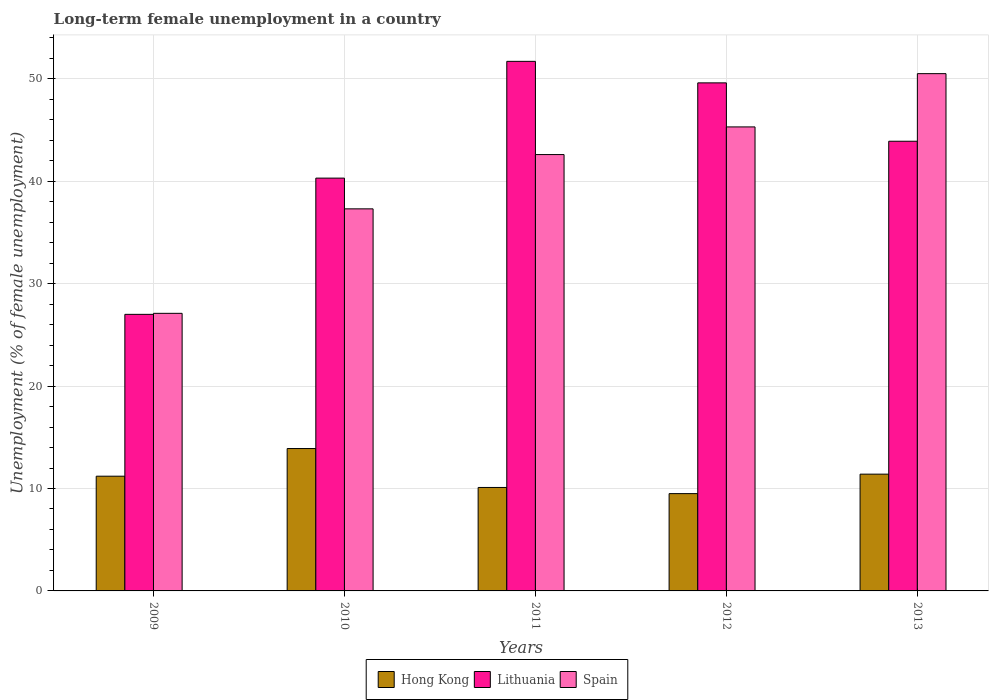How many different coloured bars are there?
Provide a succinct answer. 3. Are the number of bars on each tick of the X-axis equal?
Keep it short and to the point. Yes. How many bars are there on the 2nd tick from the left?
Provide a short and direct response. 3. How many bars are there on the 2nd tick from the right?
Offer a terse response. 3. In how many cases, is the number of bars for a given year not equal to the number of legend labels?
Your answer should be very brief. 0. What is the percentage of long-term unemployed female population in Hong Kong in 2013?
Offer a terse response. 11.4. Across all years, what is the maximum percentage of long-term unemployed female population in Lithuania?
Keep it short and to the point. 51.7. In which year was the percentage of long-term unemployed female population in Lithuania minimum?
Your response must be concise. 2009. What is the total percentage of long-term unemployed female population in Hong Kong in the graph?
Make the answer very short. 56.1. What is the difference between the percentage of long-term unemployed female population in Spain in 2009 and that in 2013?
Your response must be concise. -23.4. What is the difference between the percentage of long-term unemployed female population in Lithuania in 2010 and the percentage of long-term unemployed female population in Hong Kong in 2012?
Keep it short and to the point. 30.8. What is the average percentage of long-term unemployed female population in Hong Kong per year?
Your answer should be very brief. 11.22. In the year 2012, what is the difference between the percentage of long-term unemployed female population in Spain and percentage of long-term unemployed female population in Hong Kong?
Provide a short and direct response. 35.8. What is the ratio of the percentage of long-term unemployed female population in Lithuania in 2009 to that in 2010?
Keep it short and to the point. 0.67. What is the difference between the highest and the second highest percentage of long-term unemployed female population in Lithuania?
Your answer should be compact. 2.1. What is the difference between the highest and the lowest percentage of long-term unemployed female population in Spain?
Ensure brevity in your answer.  23.4. In how many years, is the percentage of long-term unemployed female population in Hong Kong greater than the average percentage of long-term unemployed female population in Hong Kong taken over all years?
Keep it short and to the point. 2. What does the 1st bar from the left in 2009 represents?
Offer a terse response. Hong Kong. What does the 3rd bar from the right in 2011 represents?
Your answer should be compact. Hong Kong. Is it the case that in every year, the sum of the percentage of long-term unemployed female population in Spain and percentage of long-term unemployed female population in Hong Kong is greater than the percentage of long-term unemployed female population in Lithuania?
Your answer should be compact. Yes. What is the difference between two consecutive major ticks on the Y-axis?
Provide a short and direct response. 10. Where does the legend appear in the graph?
Offer a very short reply. Bottom center. How are the legend labels stacked?
Your response must be concise. Horizontal. What is the title of the graph?
Provide a succinct answer. Long-term female unemployment in a country. Does "West Bank and Gaza" appear as one of the legend labels in the graph?
Offer a very short reply. No. What is the label or title of the Y-axis?
Give a very brief answer. Unemployment (% of female unemployment). What is the Unemployment (% of female unemployment) in Hong Kong in 2009?
Ensure brevity in your answer.  11.2. What is the Unemployment (% of female unemployment) of Spain in 2009?
Offer a very short reply. 27.1. What is the Unemployment (% of female unemployment) of Hong Kong in 2010?
Your response must be concise. 13.9. What is the Unemployment (% of female unemployment) of Lithuania in 2010?
Your response must be concise. 40.3. What is the Unemployment (% of female unemployment) of Spain in 2010?
Give a very brief answer. 37.3. What is the Unemployment (% of female unemployment) in Hong Kong in 2011?
Your answer should be compact. 10.1. What is the Unemployment (% of female unemployment) in Lithuania in 2011?
Give a very brief answer. 51.7. What is the Unemployment (% of female unemployment) in Spain in 2011?
Keep it short and to the point. 42.6. What is the Unemployment (% of female unemployment) in Lithuania in 2012?
Make the answer very short. 49.6. What is the Unemployment (% of female unemployment) of Spain in 2012?
Your answer should be very brief. 45.3. What is the Unemployment (% of female unemployment) of Hong Kong in 2013?
Your answer should be compact. 11.4. What is the Unemployment (% of female unemployment) in Lithuania in 2013?
Give a very brief answer. 43.9. What is the Unemployment (% of female unemployment) of Spain in 2013?
Your answer should be very brief. 50.5. Across all years, what is the maximum Unemployment (% of female unemployment) in Hong Kong?
Give a very brief answer. 13.9. Across all years, what is the maximum Unemployment (% of female unemployment) of Lithuania?
Offer a terse response. 51.7. Across all years, what is the maximum Unemployment (% of female unemployment) of Spain?
Make the answer very short. 50.5. Across all years, what is the minimum Unemployment (% of female unemployment) in Spain?
Provide a succinct answer. 27.1. What is the total Unemployment (% of female unemployment) in Hong Kong in the graph?
Give a very brief answer. 56.1. What is the total Unemployment (% of female unemployment) in Lithuania in the graph?
Make the answer very short. 212.5. What is the total Unemployment (% of female unemployment) in Spain in the graph?
Your response must be concise. 202.8. What is the difference between the Unemployment (% of female unemployment) in Spain in 2009 and that in 2010?
Provide a short and direct response. -10.2. What is the difference between the Unemployment (% of female unemployment) in Lithuania in 2009 and that in 2011?
Provide a succinct answer. -24.7. What is the difference between the Unemployment (% of female unemployment) in Spain in 2009 and that in 2011?
Your response must be concise. -15.5. What is the difference between the Unemployment (% of female unemployment) of Lithuania in 2009 and that in 2012?
Provide a short and direct response. -22.6. What is the difference between the Unemployment (% of female unemployment) of Spain in 2009 and that in 2012?
Your response must be concise. -18.2. What is the difference between the Unemployment (% of female unemployment) of Lithuania in 2009 and that in 2013?
Give a very brief answer. -16.9. What is the difference between the Unemployment (% of female unemployment) in Spain in 2009 and that in 2013?
Give a very brief answer. -23.4. What is the difference between the Unemployment (% of female unemployment) of Lithuania in 2010 and that in 2011?
Offer a very short reply. -11.4. What is the difference between the Unemployment (% of female unemployment) of Hong Kong in 2010 and that in 2012?
Offer a very short reply. 4.4. What is the difference between the Unemployment (% of female unemployment) of Lithuania in 2011 and that in 2012?
Your answer should be compact. 2.1. What is the difference between the Unemployment (% of female unemployment) in Spain in 2011 and that in 2012?
Make the answer very short. -2.7. What is the difference between the Unemployment (% of female unemployment) of Hong Kong in 2011 and that in 2013?
Your response must be concise. -1.3. What is the difference between the Unemployment (% of female unemployment) of Lithuania in 2011 and that in 2013?
Offer a very short reply. 7.8. What is the difference between the Unemployment (% of female unemployment) in Spain in 2011 and that in 2013?
Your answer should be very brief. -7.9. What is the difference between the Unemployment (% of female unemployment) of Hong Kong in 2012 and that in 2013?
Make the answer very short. -1.9. What is the difference between the Unemployment (% of female unemployment) in Spain in 2012 and that in 2013?
Your answer should be very brief. -5.2. What is the difference between the Unemployment (% of female unemployment) of Hong Kong in 2009 and the Unemployment (% of female unemployment) of Lithuania in 2010?
Give a very brief answer. -29.1. What is the difference between the Unemployment (% of female unemployment) in Hong Kong in 2009 and the Unemployment (% of female unemployment) in Spain in 2010?
Provide a short and direct response. -26.1. What is the difference between the Unemployment (% of female unemployment) of Hong Kong in 2009 and the Unemployment (% of female unemployment) of Lithuania in 2011?
Your answer should be compact. -40.5. What is the difference between the Unemployment (% of female unemployment) of Hong Kong in 2009 and the Unemployment (% of female unemployment) of Spain in 2011?
Provide a short and direct response. -31.4. What is the difference between the Unemployment (% of female unemployment) of Lithuania in 2009 and the Unemployment (% of female unemployment) of Spain in 2011?
Give a very brief answer. -15.6. What is the difference between the Unemployment (% of female unemployment) in Hong Kong in 2009 and the Unemployment (% of female unemployment) in Lithuania in 2012?
Your answer should be compact. -38.4. What is the difference between the Unemployment (% of female unemployment) in Hong Kong in 2009 and the Unemployment (% of female unemployment) in Spain in 2012?
Make the answer very short. -34.1. What is the difference between the Unemployment (% of female unemployment) of Lithuania in 2009 and the Unemployment (% of female unemployment) of Spain in 2012?
Provide a succinct answer. -18.3. What is the difference between the Unemployment (% of female unemployment) of Hong Kong in 2009 and the Unemployment (% of female unemployment) of Lithuania in 2013?
Offer a terse response. -32.7. What is the difference between the Unemployment (% of female unemployment) in Hong Kong in 2009 and the Unemployment (% of female unemployment) in Spain in 2013?
Your answer should be very brief. -39.3. What is the difference between the Unemployment (% of female unemployment) in Lithuania in 2009 and the Unemployment (% of female unemployment) in Spain in 2013?
Provide a short and direct response. -23.5. What is the difference between the Unemployment (% of female unemployment) of Hong Kong in 2010 and the Unemployment (% of female unemployment) of Lithuania in 2011?
Your response must be concise. -37.8. What is the difference between the Unemployment (% of female unemployment) in Hong Kong in 2010 and the Unemployment (% of female unemployment) in Spain in 2011?
Ensure brevity in your answer.  -28.7. What is the difference between the Unemployment (% of female unemployment) in Hong Kong in 2010 and the Unemployment (% of female unemployment) in Lithuania in 2012?
Make the answer very short. -35.7. What is the difference between the Unemployment (% of female unemployment) in Hong Kong in 2010 and the Unemployment (% of female unemployment) in Spain in 2012?
Offer a terse response. -31.4. What is the difference between the Unemployment (% of female unemployment) in Lithuania in 2010 and the Unemployment (% of female unemployment) in Spain in 2012?
Your answer should be very brief. -5. What is the difference between the Unemployment (% of female unemployment) of Hong Kong in 2010 and the Unemployment (% of female unemployment) of Spain in 2013?
Offer a terse response. -36.6. What is the difference between the Unemployment (% of female unemployment) in Lithuania in 2010 and the Unemployment (% of female unemployment) in Spain in 2013?
Your answer should be very brief. -10.2. What is the difference between the Unemployment (% of female unemployment) in Hong Kong in 2011 and the Unemployment (% of female unemployment) in Lithuania in 2012?
Offer a terse response. -39.5. What is the difference between the Unemployment (% of female unemployment) in Hong Kong in 2011 and the Unemployment (% of female unemployment) in Spain in 2012?
Your answer should be very brief. -35.2. What is the difference between the Unemployment (% of female unemployment) in Hong Kong in 2011 and the Unemployment (% of female unemployment) in Lithuania in 2013?
Your answer should be very brief. -33.8. What is the difference between the Unemployment (% of female unemployment) of Hong Kong in 2011 and the Unemployment (% of female unemployment) of Spain in 2013?
Your answer should be very brief. -40.4. What is the difference between the Unemployment (% of female unemployment) of Hong Kong in 2012 and the Unemployment (% of female unemployment) of Lithuania in 2013?
Ensure brevity in your answer.  -34.4. What is the difference between the Unemployment (% of female unemployment) of Hong Kong in 2012 and the Unemployment (% of female unemployment) of Spain in 2013?
Offer a terse response. -41. What is the difference between the Unemployment (% of female unemployment) in Lithuania in 2012 and the Unemployment (% of female unemployment) in Spain in 2013?
Your response must be concise. -0.9. What is the average Unemployment (% of female unemployment) of Hong Kong per year?
Offer a very short reply. 11.22. What is the average Unemployment (% of female unemployment) of Lithuania per year?
Provide a short and direct response. 42.5. What is the average Unemployment (% of female unemployment) of Spain per year?
Ensure brevity in your answer.  40.56. In the year 2009, what is the difference between the Unemployment (% of female unemployment) of Hong Kong and Unemployment (% of female unemployment) of Lithuania?
Give a very brief answer. -15.8. In the year 2009, what is the difference between the Unemployment (% of female unemployment) in Hong Kong and Unemployment (% of female unemployment) in Spain?
Keep it short and to the point. -15.9. In the year 2010, what is the difference between the Unemployment (% of female unemployment) in Hong Kong and Unemployment (% of female unemployment) in Lithuania?
Make the answer very short. -26.4. In the year 2010, what is the difference between the Unemployment (% of female unemployment) in Hong Kong and Unemployment (% of female unemployment) in Spain?
Your answer should be compact. -23.4. In the year 2010, what is the difference between the Unemployment (% of female unemployment) in Lithuania and Unemployment (% of female unemployment) in Spain?
Ensure brevity in your answer.  3. In the year 2011, what is the difference between the Unemployment (% of female unemployment) of Hong Kong and Unemployment (% of female unemployment) of Lithuania?
Offer a very short reply. -41.6. In the year 2011, what is the difference between the Unemployment (% of female unemployment) in Hong Kong and Unemployment (% of female unemployment) in Spain?
Give a very brief answer. -32.5. In the year 2011, what is the difference between the Unemployment (% of female unemployment) of Lithuania and Unemployment (% of female unemployment) of Spain?
Offer a terse response. 9.1. In the year 2012, what is the difference between the Unemployment (% of female unemployment) in Hong Kong and Unemployment (% of female unemployment) in Lithuania?
Provide a short and direct response. -40.1. In the year 2012, what is the difference between the Unemployment (% of female unemployment) of Hong Kong and Unemployment (% of female unemployment) of Spain?
Offer a very short reply. -35.8. In the year 2013, what is the difference between the Unemployment (% of female unemployment) in Hong Kong and Unemployment (% of female unemployment) in Lithuania?
Ensure brevity in your answer.  -32.5. In the year 2013, what is the difference between the Unemployment (% of female unemployment) in Hong Kong and Unemployment (% of female unemployment) in Spain?
Your answer should be compact. -39.1. What is the ratio of the Unemployment (% of female unemployment) in Hong Kong in 2009 to that in 2010?
Offer a very short reply. 0.81. What is the ratio of the Unemployment (% of female unemployment) in Lithuania in 2009 to that in 2010?
Your answer should be very brief. 0.67. What is the ratio of the Unemployment (% of female unemployment) of Spain in 2009 to that in 2010?
Provide a succinct answer. 0.73. What is the ratio of the Unemployment (% of female unemployment) of Hong Kong in 2009 to that in 2011?
Provide a succinct answer. 1.11. What is the ratio of the Unemployment (% of female unemployment) of Lithuania in 2009 to that in 2011?
Your answer should be compact. 0.52. What is the ratio of the Unemployment (% of female unemployment) of Spain in 2009 to that in 2011?
Your response must be concise. 0.64. What is the ratio of the Unemployment (% of female unemployment) in Hong Kong in 2009 to that in 2012?
Keep it short and to the point. 1.18. What is the ratio of the Unemployment (% of female unemployment) in Lithuania in 2009 to that in 2012?
Give a very brief answer. 0.54. What is the ratio of the Unemployment (% of female unemployment) of Spain in 2009 to that in 2012?
Make the answer very short. 0.6. What is the ratio of the Unemployment (% of female unemployment) in Hong Kong in 2009 to that in 2013?
Your answer should be very brief. 0.98. What is the ratio of the Unemployment (% of female unemployment) in Lithuania in 2009 to that in 2013?
Make the answer very short. 0.61. What is the ratio of the Unemployment (% of female unemployment) of Spain in 2009 to that in 2013?
Provide a succinct answer. 0.54. What is the ratio of the Unemployment (% of female unemployment) in Hong Kong in 2010 to that in 2011?
Your answer should be compact. 1.38. What is the ratio of the Unemployment (% of female unemployment) in Lithuania in 2010 to that in 2011?
Provide a short and direct response. 0.78. What is the ratio of the Unemployment (% of female unemployment) in Spain in 2010 to that in 2011?
Ensure brevity in your answer.  0.88. What is the ratio of the Unemployment (% of female unemployment) of Hong Kong in 2010 to that in 2012?
Provide a succinct answer. 1.46. What is the ratio of the Unemployment (% of female unemployment) in Lithuania in 2010 to that in 2012?
Offer a very short reply. 0.81. What is the ratio of the Unemployment (% of female unemployment) in Spain in 2010 to that in 2012?
Keep it short and to the point. 0.82. What is the ratio of the Unemployment (% of female unemployment) in Hong Kong in 2010 to that in 2013?
Offer a terse response. 1.22. What is the ratio of the Unemployment (% of female unemployment) in Lithuania in 2010 to that in 2013?
Provide a short and direct response. 0.92. What is the ratio of the Unemployment (% of female unemployment) of Spain in 2010 to that in 2013?
Make the answer very short. 0.74. What is the ratio of the Unemployment (% of female unemployment) of Hong Kong in 2011 to that in 2012?
Make the answer very short. 1.06. What is the ratio of the Unemployment (% of female unemployment) of Lithuania in 2011 to that in 2012?
Offer a terse response. 1.04. What is the ratio of the Unemployment (% of female unemployment) of Spain in 2011 to that in 2012?
Your response must be concise. 0.94. What is the ratio of the Unemployment (% of female unemployment) in Hong Kong in 2011 to that in 2013?
Provide a succinct answer. 0.89. What is the ratio of the Unemployment (% of female unemployment) of Lithuania in 2011 to that in 2013?
Offer a terse response. 1.18. What is the ratio of the Unemployment (% of female unemployment) of Spain in 2011 to that in 2013?
Provide a short and direct response. 0.84. What is the ratio of the Unemployment (% of female unemployment) of Lithuania in 2012 to that in 2013?
Keep it short and to the point. 1.13. What is the ratio of the Unemployment (% of female unemployment) of Spain in 2012 to that in 2013?
Ensure brevity in your answer.  0.9. What is the difference between the highest and the lowest Unemployment (% of female unemployment) in Lithuania?
Your response must be concise. 24.7. What is the difference between the highest and the lowest Unemployment (% of female unemployment) of Spain?
Your answer should be compact. 23.4. 